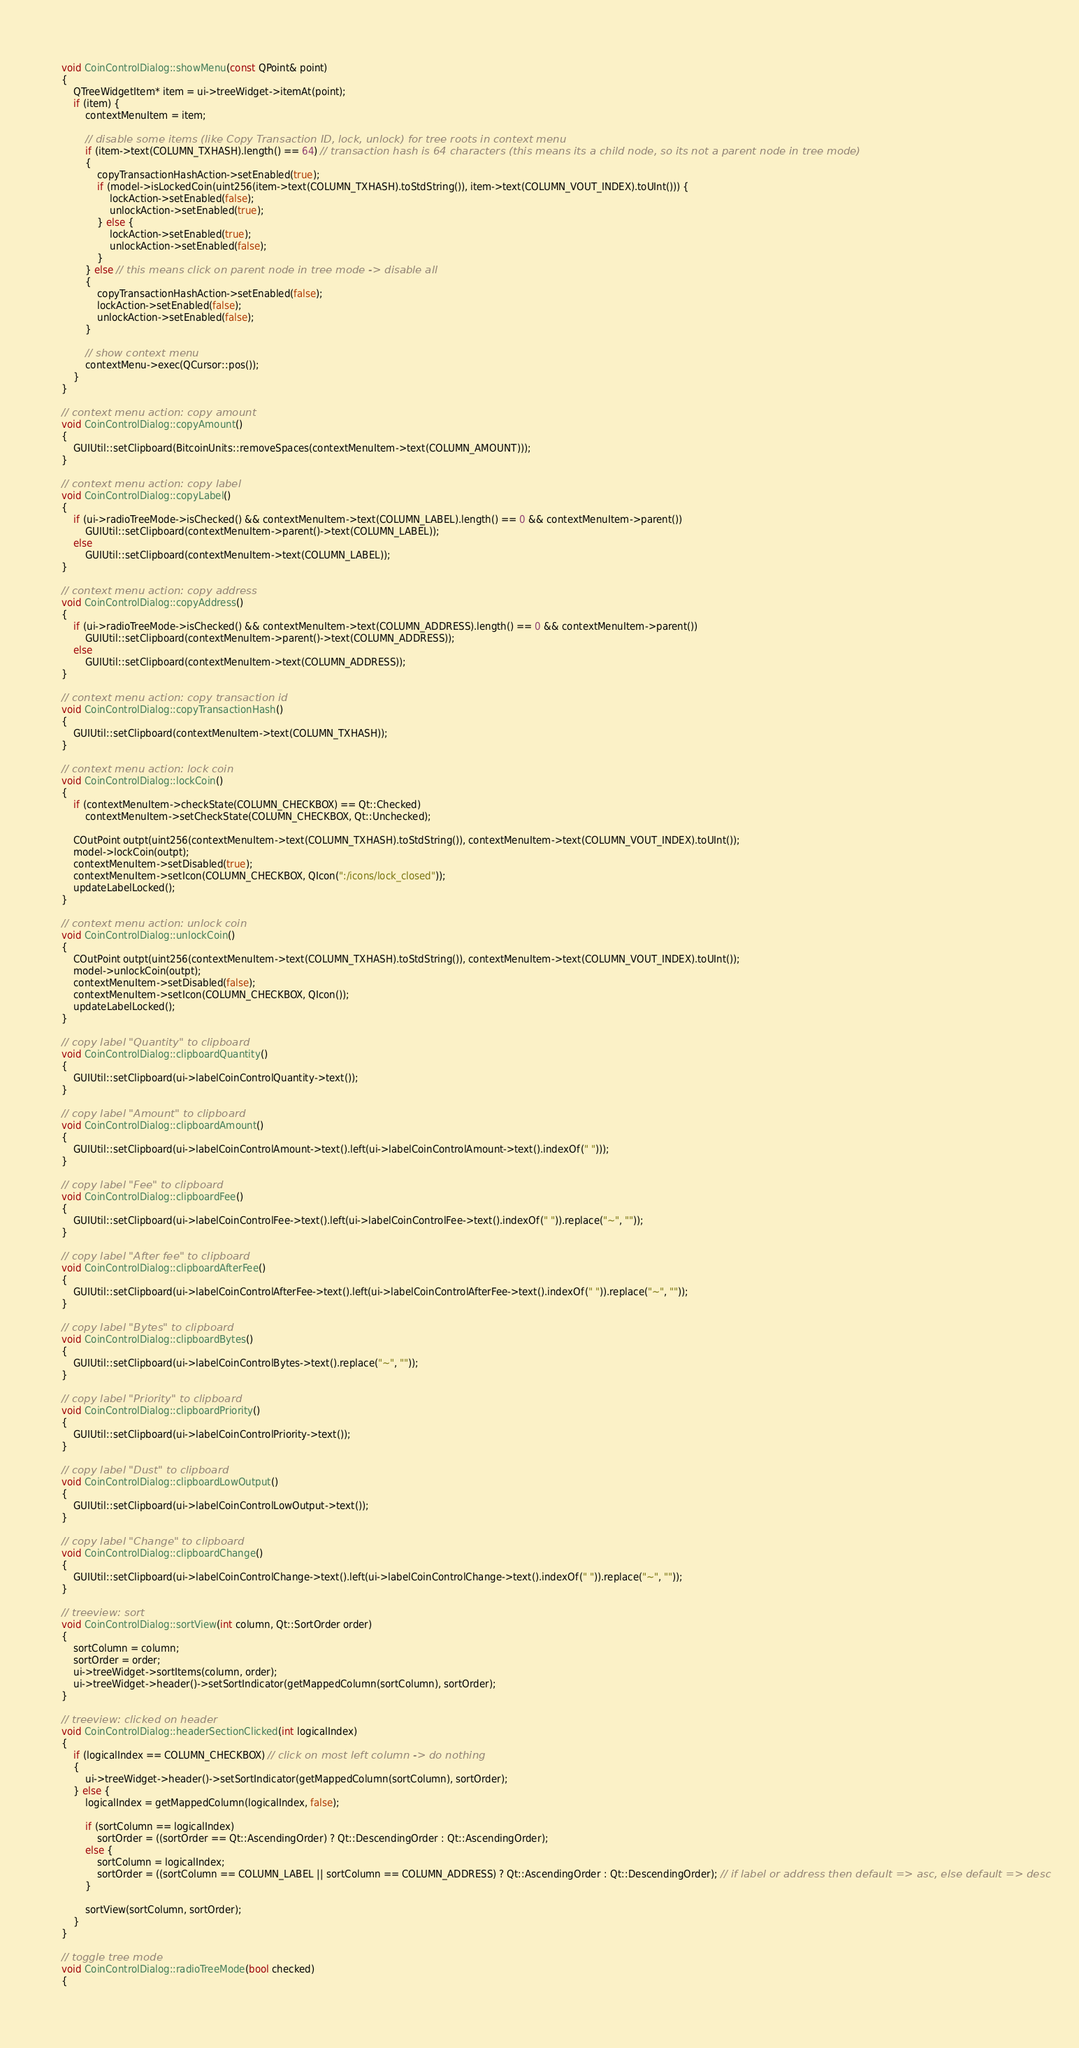Convert code to text. <code><loc_0><loc_0><loc_500><loc_500><_C++_>void CoinControlDialog::showMenu(const QPoint& point)
{
    QTreeWidgetItem* item = ui->treeWidget->itemAt(point);
    if (item) {
        contextMenuItem = item;

        // disable some items (like Copy Transaction ID, lock, unlock) for tree roots in context menu
        if (item->text(COLUMN_TXHASH).length() == 64) // transaction hash is 64 characters (this means its a child node, so its not a parent node in tree mode)
        {
            copyTransactionHashAction->setEnabled(true);
            if (model->isLockedCoin(uint256(item->text(COLUMN_TXHASH).toStdString()), item->text(COLUMN_VOUT_INDEX).toUInt())) {
                lockAction->setEnabled(false);
                unlockAction->setEnabled(true);
            } else {
                lockAction->setEnabled(true);
                unlockAction->setEnabled(false);
            }
        } else // this means click on parent node in tree mode -> disable all
        {
            copyTransactionHashAction->setEnabled(false);
            lockAction->setEnabled(false);
            unlockAction->setEnabled(false);
        }

        // show context menu
        contextMenu->exec(QCursor::pos());
    }
}

// context menu action: copy amount
void CoinControlDialog::copyAmount()
{
    GUIUtil::setClipboard(BitcoinUnits::removeSpaces(contextMenuItem->text(COLUMN_AMOUNT)));
}

// context menu action: copy label
void CoinControlDialog::copyLabel()
{
    if (ui->radioTreeMode->isChecked() && contextMenuItem->text(COLUMN_LABEL).length() == 0 && contextMenuItem->parent())
        GUIUtil::setClipboard(contextMenuItem->parent()->text(COLUMN_LABEL));
    else
        GUIUtil::setClipboard(contextMenuItem->text(COLUMN_LABEL));
}

// context menu action: copy address
void CoinControlDialog::copyAddress()
{
    if (ui->radioTreeMode->isChecked() && contextMenuItem->text(COLUMN_ADDRESS).length() == 0 && contextMenuItem->parent())
        GUIUtil::setClipboard(contextMenuItem->parent()->text(COLUMN_ADDRESS));
    else
        GUIUtil::setClipboard(contextMenuItem->text(COLUMN_ADDRESS));
}

// context menu action: copy transaction id
void CoinControlDialog::copyTransactionHash()
{
    GUIUtil::setClipboard(contextMenuItem->text(COLUMN_TXHASH));
}

// context menu action: lock coin
void CoinControlDialog::lockCoin()
{
    if (contextMenuItem->checkState(COLUMN_CHECKBOX) == Qt::Checked)
        contextMenuItem->setCheckState(COLUMN_CHECKBOX, Qt::Unchecked);

    COutPoint outpt(uint256(contextMenuItem->text(COLUMN_TXHASH).toStdString()), contextMenuItem->text(COLUMN_VOUT_INDEX).toUInt());
    model->lockCoin(outpt);
    contextMenuItem->setDisabled(true);
    contextMenuItem->setIcon(COLUMN_CHECKBOX, QIcon(":/icons/lock_closed"));
    updateLabelLocked();
}

// context menu action: unlock coin
void CoinControlDialog::unlockCoin()
{
    COutPoint outpt(uint256(contextMenuItem->text(COLUMN_TXHASH).toStdString()), contextMenuItem->text(COLUMN_VOUT_INDEX).toUInt());
    model->unlockCoin(outpt);
    contextMenuItem->setDisabled(false);
    contextMenuItem->setIcon(COLUMN_CHECKBOX, QIcon());
    updateLabelLocked();
}

// copy label "Quantity" to clipboard
void CoinControlDialog::clipboardQuantity()
{
    GUIUtil::setClipboard(ui->labelCoinControlQuantity->text());
}

// copy label "Amount" to clipboard
void CoinControlDialog::clipboardAmount()
{
    GUIUtil::setClipboard(ui->labelCoinControlAmount->text().left(ui->labelCoinControlAmount->text().indexOf(" ")));
}

// copy label "Fee" to clipboard
void CoinControlDialog::clipboardFee()
{
    GUIUtil::setClipboard(ui->labelCoinControlFee->text().left(ui->labelCoinControlFee->text().indexOf(" ")).replace("~", ""));
}

// copy label "After fee" to clipboard
void CoinControlDialog::clipboardAfterFee()
{
    GUIUtil::setClipboard(ui->labelCoinControlAfterFee->text().left(ui->labelCoinControlAfterFee->text().indexOf(" ")).replace("~", ""));
}

// copy label "Bytes" to clipboard
void CoinControlDialog::clipboardBytes()
{
    GUIUtil::setClipboard(ui->labelCoinControlBytes->text().replace("~", ""));
}

// copy label "Priority" to clipboard
void CoinControlDialog::clipboardPriority()
{
    GUIUtil::setClipboard(ui->labelCoinControlPriority->text());
}

// copy label "Dust" to clipboard
void CoinControlDialog::clipboardLowOutput()
{
    GUIUtil::setClipboard(ui->labelCoinControlLowOutput->text());
}

// copy label "Change" to clipboard
void CoinControlDialog::clipboardChange()
{
    GUIUtil::setClipboard(ui->labelCoinControlChange->text().left(ui->labelCoinControlChange->text().indexOf(" ")).replace("~", ""));
}

// treeview: sort
void CoinControlDialog::sortView(int column, Qt::SortOrder order)
{
    sortColumn = column;
    sortOrder = order;
    ui->treeWidget->sortItems(column, order);
    ui->treeWidget->header()->setSortIndicator(getMappedColumn(sortColumn), sortOrder);
}

// treeview: clicked on header
void CoinControlDialog::headerSectionClicked(int logicalIndex)
{
    if (logicalIndex == COLUMN_CHECKBOX) // click on most left column -> do nothing
    {
        ui->treeWidget->header()->setSortIndicator(getMappedColumn(sortColumn), sortOrder);
    } else {
        logicalIndex = getMappedColumn(logicalIndex, false);

        if (sortColumn == logicalIndex)
            sortOrder = ((sortOrder == Qt::AscendingOrder) ? Qt::DescendingOrder : Qt::AscendingOrder);
        else {
            sortColumn = logicalIndex;
            sortOrder = ((sortColumn == COLUMN_LABEL || sortColumn == COLUMN_ADDRESS) ? Qt::AscendingOrder : Qt::DescendingOrder); // if label or address then default => asc, else default => desc
        }

        sortView(sortColumn, sortOrder);
    }
}

// toggle tree mode
void CoinControlDialog::radioTreeMode(bool checked)
{</code> 